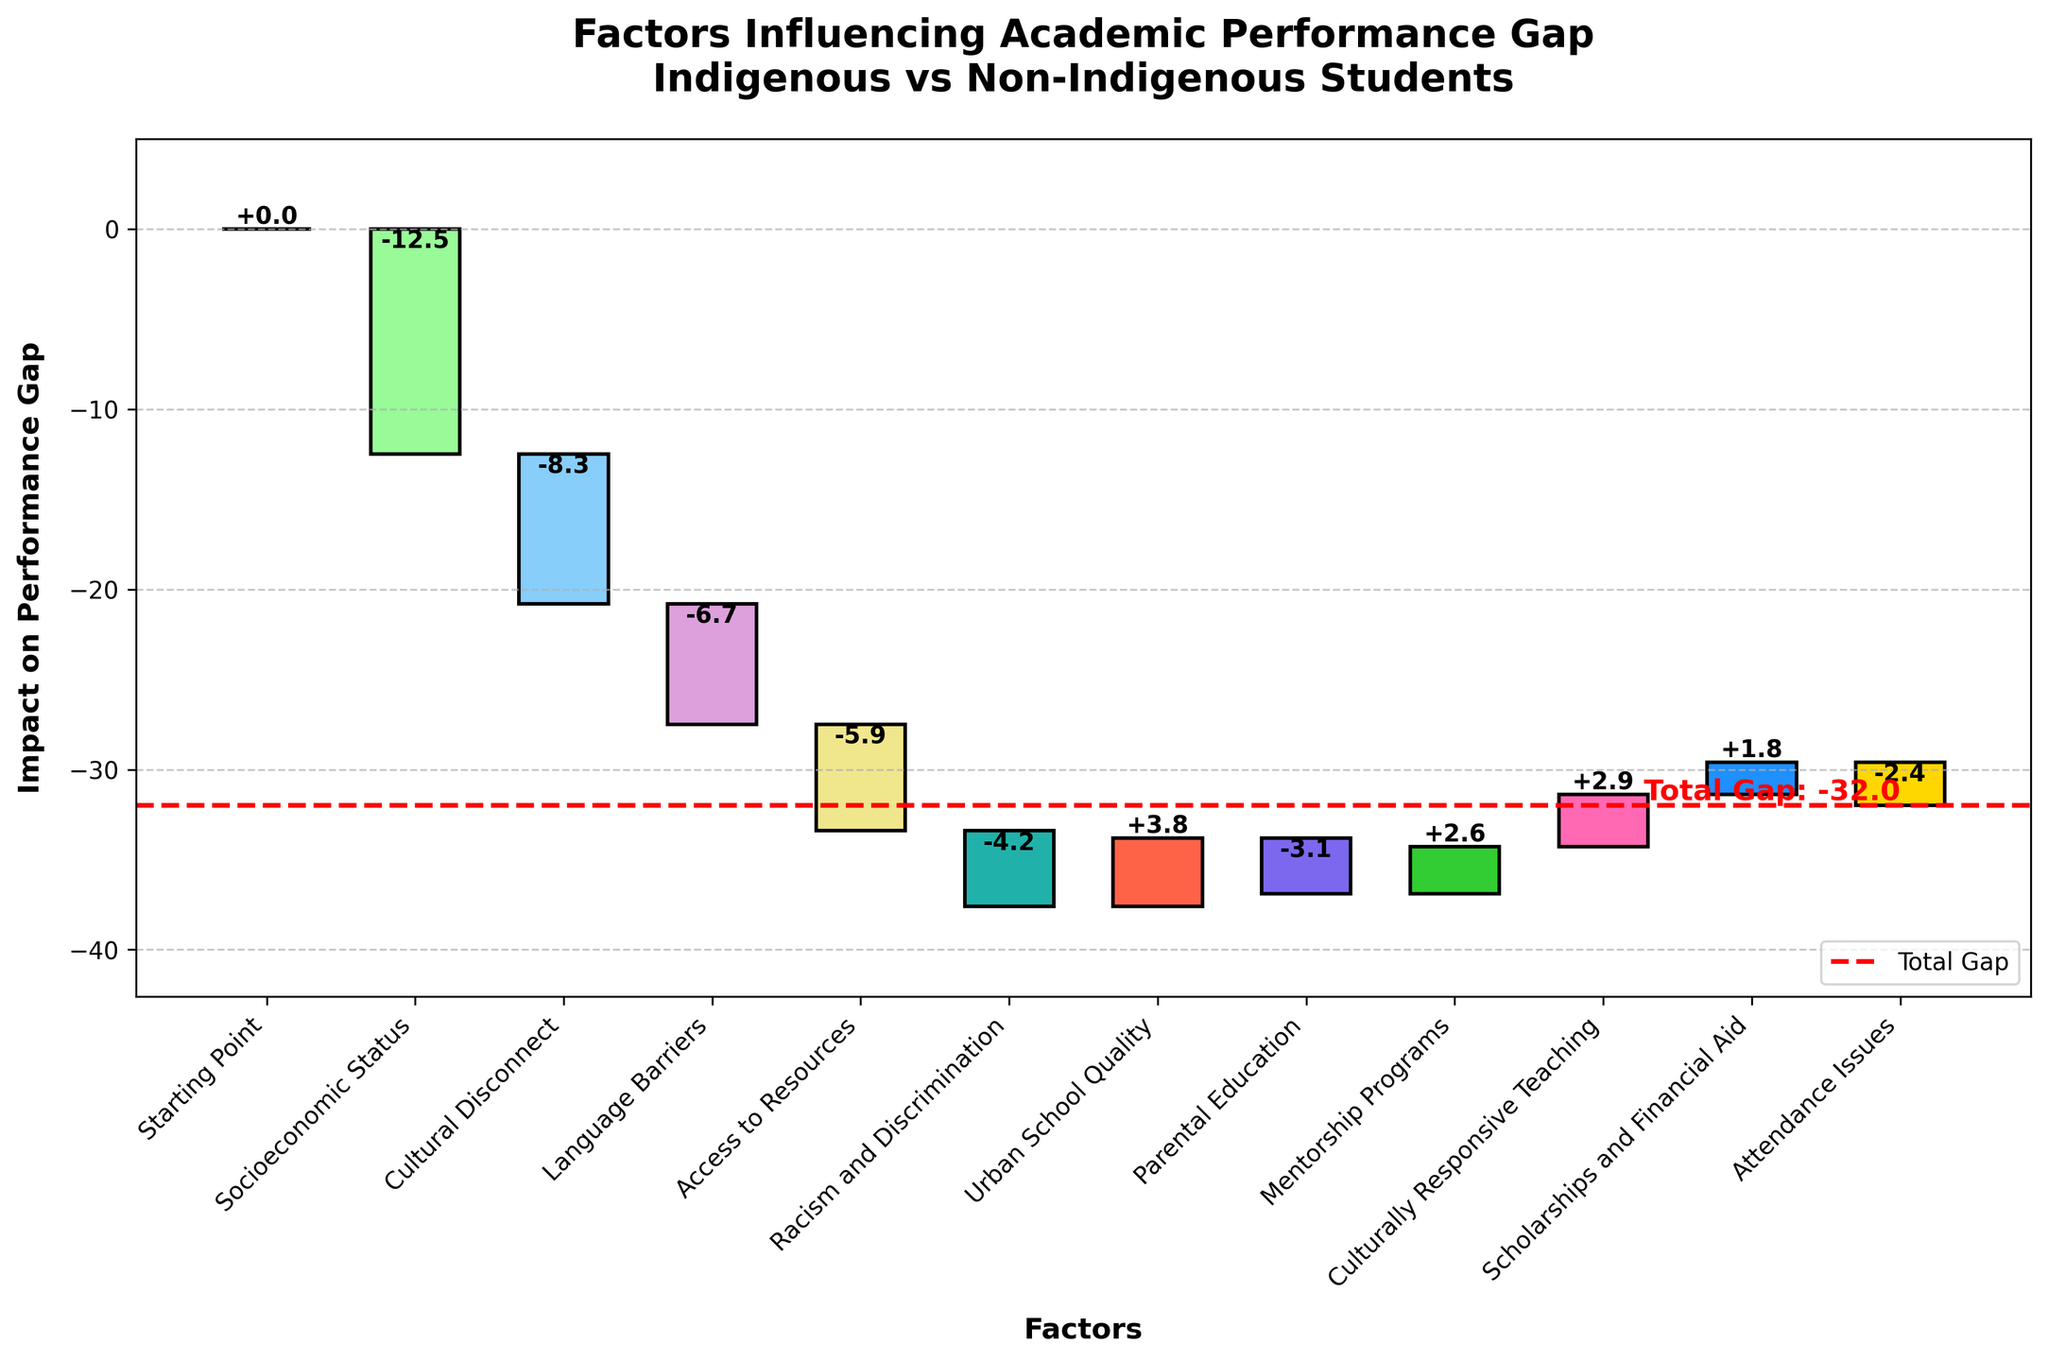What's the title of the chart? The title of the chart is located at the top, providing the main description of what the chart represents. In this case, it reads "Factors Influencing Academic Performance Gap - Indigenous vs Non-Indigenous Students".
Answer: Factors Influencing Academic Performance Gap - Indigenous vs Non-Indigenous Students What is the impact of Socioeconomic Status on the academic performance gap? You can find this in the bar labeled "Socioeconomic Status". The value is represented visually and numerically on the chart itself. It shows a negative value of -12.5.
Answer: -12.5 How many factors contribute positively to the performance gap? To get this number, look at all the bars that have positive values. In the chart, the factors with positive contributions are: Urban School Quality, Mentorship Programs, Culturally Responsive Teaching, and Scholarships and Financial Aid. There are four such factors.
Answer: 4 Which factor has the most negative impact on the performance gap? To find this, observe the bar with the largest drop compared to the others. "Socioeconomic Status" has the longest descending bar with a value of -12.5, making it the factor with the most negative impact.
Answer: Socioeconomic Status What is the total gap between Indigenous and Non-Indigenous students? The total gap is explicitly marked by a red dashed line at the end of the chart. The label attached to this line reads "Total Gap: -32".
Answer: -32 How does the impact of Access to Resources compare to that of Parental Education? Access to Resources has a value of -5.9, and Parental Education has a value of -3.1. By comparing these values, we see that Access to Resources has a larger negative impact.
Answer: Access to Resources has a larger negative impact What is the cumulative impact of Cultural Disconnect and Language Barriers? To find the cumulative impact, sum up the values of these two factors. Cultural Disconnect is -8.3, and Language Barriers is -6.7. Adding them together: -8.3 + (-6.7) = -15.0.
Answer: -15.0 Which factors have positive impacts and what are their combined effects? Identify the factors with positive values: Urban School Quality (3.8), Mentorship Programs (2.6), Culturally Responsive Teaching (2.9), and Scholarships and Financial Aid (1.8). Sum these values: 3.8 + 2.6 + 2.9 + 1.8 = 11.1.
Answer: 11.1 Which factor(s) impacts are equivalent to the impact of Cultural Disconnect? Cultural Disconnect has an impact of -8.3. Comparing with other factors, none of them have the exact same value.
Answer: None 